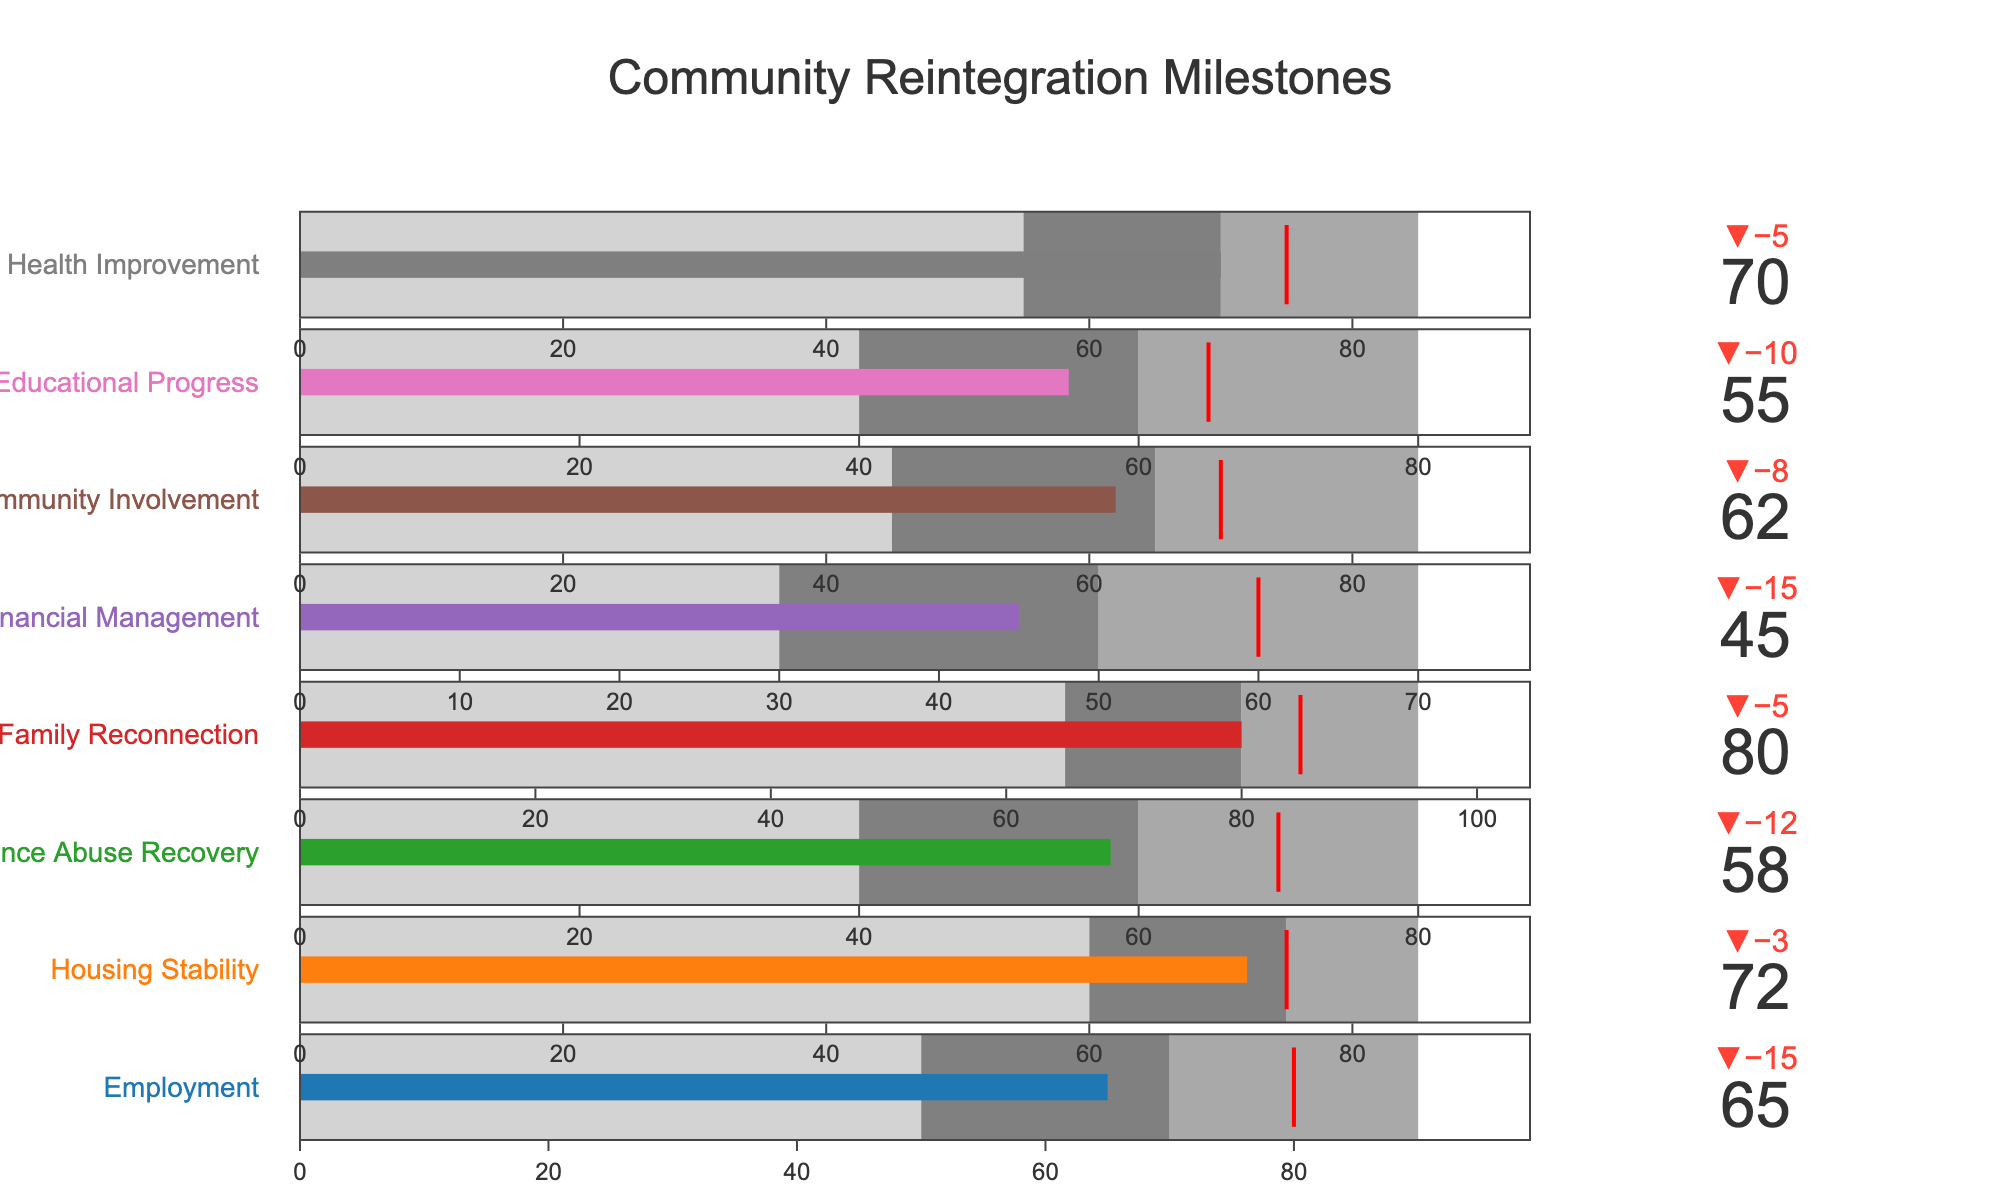What's the title of the chart? The title is usually displayed at the top of the chart and summarizes what the chart is about. In this case, it is "Community Reintegration Milestones".
Answer: Community Reintegration Milestones How many categories are displayed in the bullet chart? Count the number of distinct rows or bullet indicators shown in the chart. There are eight categories listed which represent each milestone achieved.
Answer: Eight Which category has the highest actual value achieved? Look at all the actual values and identify the highest one. For the highest value, compare "Family Reconnection" scoring 80.
Answer: Family Reconnection What is the expected target value for Financial Management? Identify the part of the bullet chart labeled "Financial Management" and find the target value, which is typically shown by a threshold indicator or a marker. Here it is 60.
Answer: 60 Which category has the largest difference between actual and target values? Calculate the difference between actual and target values for each category and then compare them. For example, Family Reconnection (80-85=-5), Financial Management (45-60=-15) etc. The largest negative difference is for Financial Management.
Answer: Financial Management Is the actual value for Educational Progress above the medium range? Check the medium range for Educational Progress, which is 40 to 60. The actual value is 55, which falls within the medium range but is not above it.
Answer: No How does the actual value for Employment compare with its target value? Compare the actual achieved value (65) with the target value (80) for Employment. 65 is lower than 80.
Answer: Lower What range does the category Substance Abuse Recovery fall into with respect to its actual value? Check where the actual value (58) falls in the range steps for Substance Abuse Recovery: low (40 to 60), medium (60 to 80). 58 is within the low range.
Answer: Low range Which categories did not meet their target value? Compare the actual and target values for each category to see which ones fell short. Employment, Substance Abuse Recovery, Financial Management, Community Involvement, Educational Progress did not meet their target values.
Answer: Employment, Substance Abuse Recovery, Financial Management, Community Involvement, Educational Progress What is the average actual value of all categories? Sum all the actual values and then divide by the number of categories. (65 + 72 + 58 + 80 + 45 + 62 + 55 + 70) = 507. Average = 507 / 8 = 63.375.
Answer: 63.375 